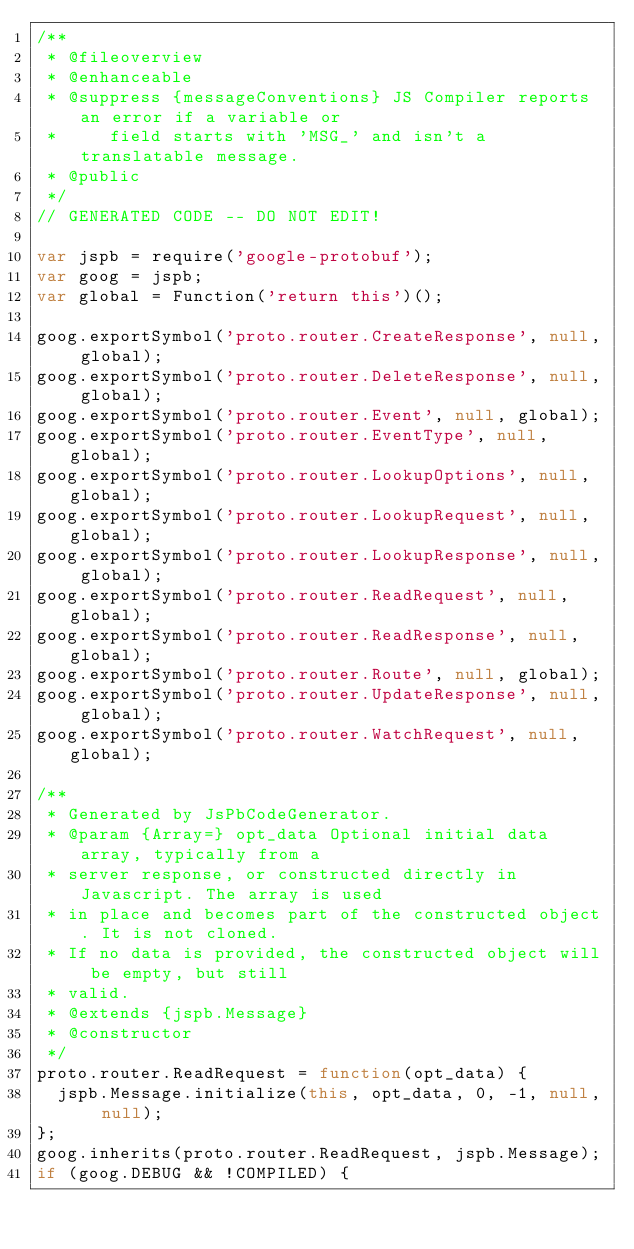Convert code to text. <code><loc_0><loc_0><loc_500><loc_500><_JavaScript_>/**
 * @fileoverview
 * @enhanceable
 * @suppress {messageConventions} JS Compiler reports an error if a variable or
 *     field starts with 'MSG_' and isn't a translatable message.
 * @public
 */
// GENERATED CODE -- DO NOT EDIT!

var jspb = require('google-protobuf');
var goog = jspb;
var global = Function('return this')();

goog.exportSymbol('proto.router.CreateResponse', null, global);
goog.exportSymbol('proto.router.DeleteResponse', null, global);
goog.exportSymbol('proto.router.Event', null, global);
goog.exportSymbol('proto.router.EventType', null, global);
goog.exportSymbol('proto.router.LookupOptions', null, global);
goog.exportSymbol('proto.router.LookupRequest', null, global);
goog.exportSymbol('proto.router.LookupResponse', null, global);
goog.exportSymbol('proto.router.ReadRequest', null, global);
goog.exportSymbol('proto.router.ReadResponse', null, global);
goog.exportSymbol('proto.router.Route', null, global);
goog.exportSymbol('proto.router.UpdateResponse', null, global);
goog.exportSymbol('proto.router.WatchRequest', null, global);

/**
 * Generated by JsPbCodeGenerator.
 * @param {Array=} opt_data Optional initial data array, typically from a
 * server response, or constructed directly in Javascript. The array is used
 * in place and becomes part of the constructed object. It is not cloned.
 * If no data is provided, the constructed object will be empty, but still
 * valid.
 * @extends {jspb.Message}
 * @constructor
 */
proto.router.ReadRequest = function(opt_data) {
  jspb.Message.initialize(this, opt_data, 0, -1, null, null);
};
goog.inherits(proto.router.ReadRequest, jspb.Message);
if (goog.DEBUG && !COMPILED) {</code> 